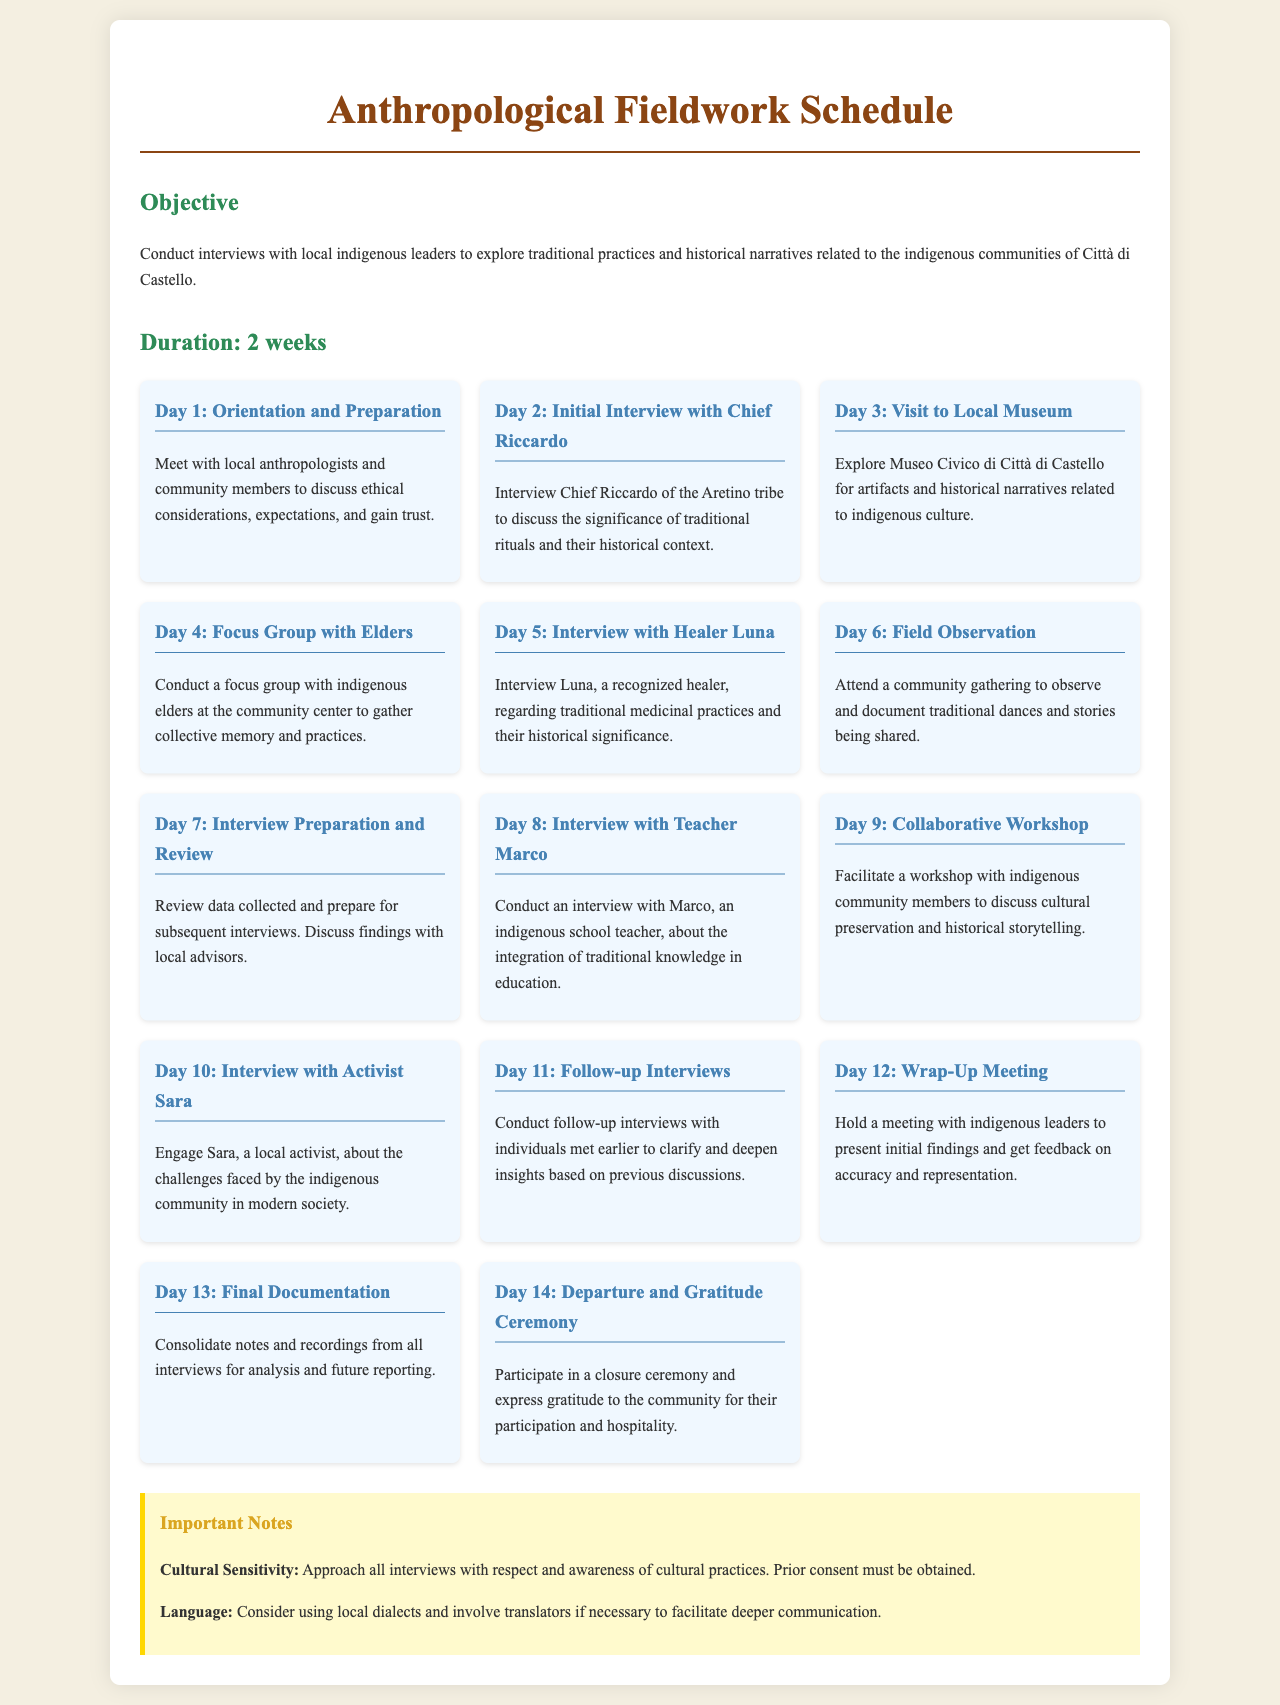What is the duration of the fieldwork? The duration of the fieldwork is explicitly stated in the document as 2 weeks.
Answer: 2 weeks Who is being interviewed on Day 2? The document specifies that Chief Riccardo of the Aretino tribe will be interviewed on Day 2.
Answer: Chief Riccardo What is the focus of Day 4's activity? Day 4 is dedicated to conducting a focus group with indigenous elders at the community center.
Answer: Focus group with Elders Which community member is interviewed about medicinal practices? The interview regarding traditional medicinal practices is with Luna, a recognized healer.
Answer: Luna What type of gathering is attended on Day 6? On Day 6, the schedule includes attending a community gathering to observe and document traditional dances and stories.
Answer: Community gathering What is the purpose of Day 12's meeting? The meeting on Day 12 serves to present initial findings and receive feedback from indigenous leaders on accuracy and representation.
Answer: Wrap-Up Meeting How many interviews are scheduled before the wrap-up meeting? The schedule indicates eight interviews are planned before the wrap-up meeting on Day 12.
Answer: Eight What are the important notes regarding cultural sensitivity? The document highlights the importance of approaching interviews with respect and awareness of cultural practices.
Answer: Cultural Sensitivity What is the final activity before departure? The last scheduled activity is a gratitude ceremony on Day 14.
Answer: Gratitude Ceremony 